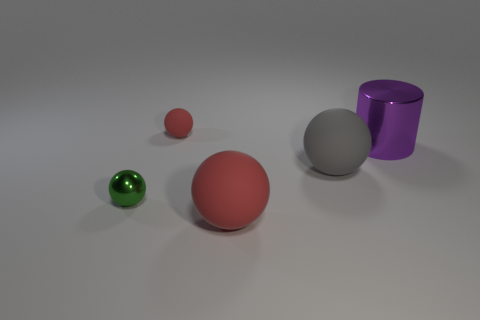Subtract all big gray balls. How many balls are left? 3 Add 4 large purple metallic cylinders. How many objects exist? 9 Subtract all red cylinders. How many red balls are left? 2 Subtract all green balls. How many balls are left? 3 Subtract 1 spheres. How many spheres are left? 3 Subtract all cylinders. How many objects are left? 4 Subtract 0 green cubes. How many objects are left? 5 Subtract all yellow balls. Subtract all red blocks. How many balls are left? 4 Subtract all green metallic balls. Subtract all large gray rubber objects. How many objects are left? 3 Add 4 large gray objects. How many large gray objects are left? 5 